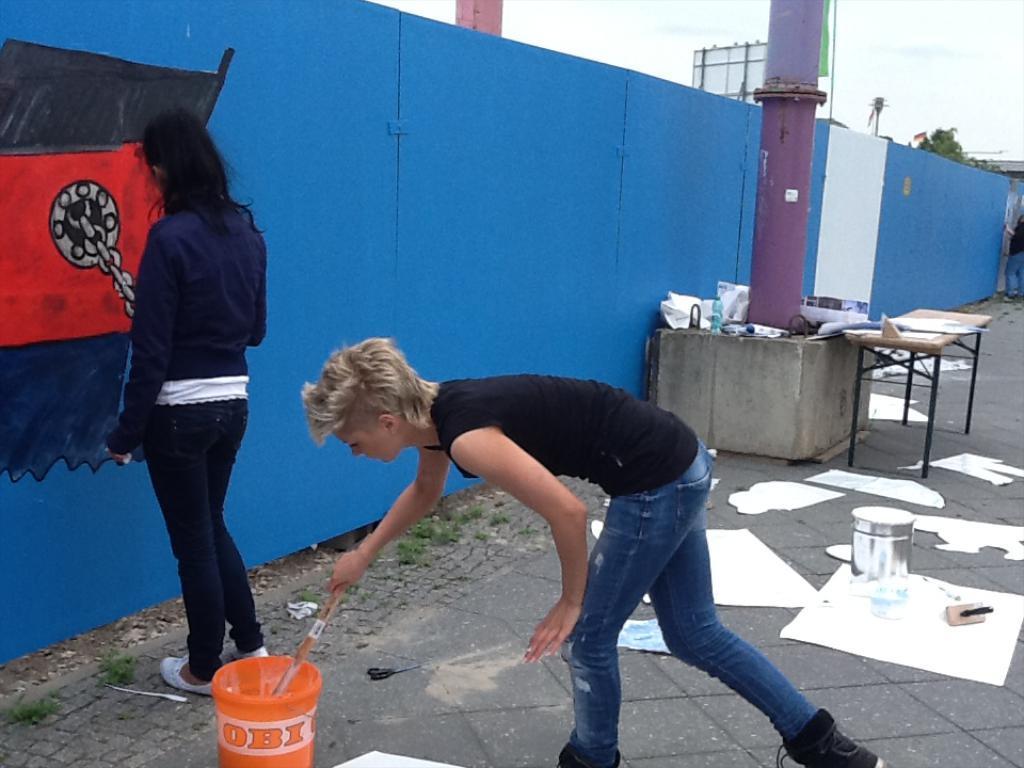How would you summarize this image in a sentence or two? In this image, there are a few people. Among them, we can see a person holding an object. We can see the blue colored wall with some art. We can also see the ground with some objects like posters, containers. There are a few tables. We can also see some poles, a board, a few leaves and the sky. 